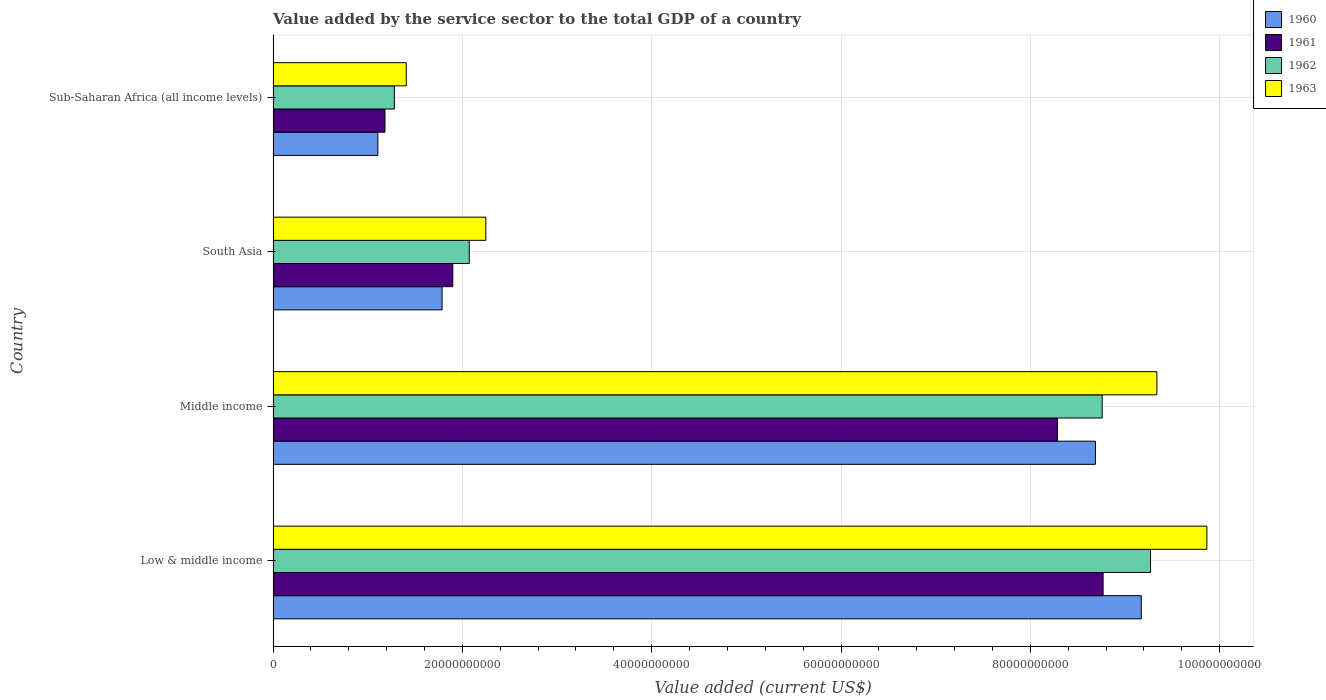How many different coloured bars are there?
Offer a terse response. 4. How many groups of bars are there?
Your response must be concise. 4. Are the number of bars on each tick of the Y-axis equal?
Ensure brevity in your answer.  Yes. What is the label of the 2nd group of bars from the top?
Keep it short and to the point. South Asia. What is the value added by the service sector to the total GDP in 1961 in South Asia?
Your response must be concise. 1.90e+1. Across all countries, what is the maximum value added by the service sector to the total GDP in 1962?
Offer a terse response. 9.27e+1. Across all countries, what is the minimum value added by the service sector to the total GDP in 1960?
Offer a very short reply. 1.11e+1. In which country was the value added by the service sector to the total GDP in 1962 maximum?
Offer a very short reply. Low & middle income. In which country was the value added by the service sector to the total GDP in 1961 minimum?
Provide a succinct answer. Sub-Saharan Africa (all income levels). What is the total value added by the service sector to the total GDP in 1962 in the graph?
Your answer should be compact. 2.14e+11. What is the difference between the value added by the service sector to the total GDP in 1962 in Low & middle income and that in South Asia?
Make the answer very short. 7.20e+1. What is the difference between the value added by the service sector to the total GDP in 1963 in Sub-Saharan Africa (all income levels) and the value added by the service sector to the total GDP in 1962 in Low & middle income?
Your response must be concise. -7.86e+1. What is the average value added by the service sector to the total GDP in 1961 per country?
Your answer should be compact. 5.03e+1. What is the difference between the value added by the service sector to the total GDP in 1961 and value added by the service sector to the total GDP in 1962 in Sub-Saharan Africa (all income levels)?
Your answer should be compact. -9.94e+08. What is the ratio of the value added by the service sector to the total GDP in 1961 in South Asia to that in Sub-Saharan Africa (all income levels)?
Keep it short and to the point. 1.61. Is the value added by the service sector to the total GDP in 1962 in Low & middle income less than that in Sub-Saharan Africa (all income levels)?
Provide a succinct answer. No. What is the difference between the highest and the second highest value added by the service sector to the total GDP in 1960?
Offer a terse response. 4.84e+09. What is the difference between the highest and the lowest value added by the service sector to the total GDP in 1963?
Provide a succinct answer. 8.46e+1. Is it the case that in every country, the sum of the value added by the service sector to the total GDP in 1963 and value added by the service sector to the total GDP in 1960 is greater than the sum of value added by the service sector to the total GDP in 1962 and value added by the service sector to the total GDP in 1961?
Your response must be concise. No. Does the graph contain any zero values?
Provide a short and direct response. No. How are the legend labels stacked?
Offer a terse response. Vertical. What is the title of the graph?
Provide a succinct answer. Value added by the service sector to the total GDP of a country. What is the label or title of the X-axis?
Your answer should be very brief. Value added (current US$). What is the label or title of the Y-axis?
Give a very brief answer. Country. What is the Value added (current US$) of 1960 in Low & middle income?
Keep it short and to the point. 9.17e+1. What is the Value added (current US$) of 1961 in Low & middle income?
Make the answer very short. 8.77e+1. What is the Value added (current US$) of 1962 in Low & middle income?
Your answer should be compact. 9.27e+1. What is the Value added (current US$) of 1963 in Low & middle income?
Your response must be concise. 9.87e+1. What is the Value added (current US$) in 1960 in Middle income?
Make the answer very short. 8.69e+1. What is the Value added (current US$) of 1961 in Middle income?
Your response must be concise. 8.29e+1. What is the Value added (current US$) in 1962 in Middle income?
Provide a short and direct response. 8.76e+1. What is the Value added (current US$) of 1963 in Middle income?
Your response must be concise. 9.34e+1. What is the Value added (current US$) of 1960 in South Asia?
Your response must be concise. 1.79e+1. What is the Value added (current US$) of 1961 in South Asia?
Offer a very short reply. 1.90e+1. What is the Value added (current US$) in 1962 in South Asia?
Provide a succinct answer. 2.07e+1. What is the Value added (current US$) in 1963 in South Asia?
Your answer should be compact. 2.25e+1. What is the Value added (current US$) of 1960 in Sub-Saharan Africa (all income levels)?
Your answer should be very brief. 1.11e+1. What is the Value added (current US$) in 1961 in Sub-Saharan Africa (all income levels)?
Give a very brief answer. 1.18e+1. What is the Value added (current US$) of 1962 in Sub-Saharan Africa (all income levels)?
Offer a terse response. 1.28e+1. What is the Value added (current US$) in 1963 in Sub-Saharan Africa (all income levels)?
Ensure brevity in your answer.  1.41e+1. Across all countries, what is the maximum Value added (current US$) in 1960?
Offer a terse response. 9.17e+1. Across all countries, what is the maximum Value added (current US$) of 1961?
Your answer should be compact. 8.77e+1. Across all countries, what is the maximum Value added (current US$) in 1962?
Offer a very short reply. 9.27e+1. Across all countries, what is the maximum Value added (current US$) in 1963?
Provide a succinct answer. 9.87e+1. Across all countries, what is the minimum Value added (current US$) in 1960?
Offer a very short reply. 1.11e+1. Across all countries, what is the minimum Value added (current US$) of 1961?
Offer a terse response. 1.18e+1. Across all countries, what is the minimum Value added (current US$) in 1962?
Provide a short and direct response. 1.28e+1. Across all countries, what is the minimum Value added (current US$) in 1963?
Ensure brevity in your answer.  1.41e+1. What is the total Value added (current US$) of 1960 in the graph?
Your response must be concise. 2.08e+11. What is the total Value added (current US$) in 1961 in the graph?
Offer a terse response. 2.01e+11. What is the total Value added (current US$) in 1962 in the graph?
Provide a short and direct response. 2.14e+11. What is the total Value added (current US$) in 1963 in the graph?
Make the answer very short. 2.29e+11. What is the difference between the Value added (current US$) in 1960 in Low & middle income and that in Middle income?
Keep it short and to the point. 4.84e+09. What is the difference between the Value added (current US$) of 1961 in Low & middle income and that in Middle income?
Keep it short and to the point. 4.82e+09. What is the difference between the Value added (current US$) in 1962 in Low & middle income and that in Middle income?
Your response must be concise. 5.11e+09. What is the difference between the Value added (current US$) in 1963 in Low & middle income and that in Middle income?
Your answer should be very brief. 5.28e+09. What is the difference between the Value added (current US$) of 1960 in Low & middle income and that in South Asia?
Give a very brief answer. 7.39e+1. What is the difference between the Value added (current US$) of 1961 in Low & middle income and that in South Asia?
Keep it short and to the point. 6.87e+1. What is the difference between the Value added (current US$) of 1962 in Low & middle income and that in South Asia?
Your response must be concise. 7.20e+1. What is the difference between the Value added (current US$) of 1963 in Low & middle income and that in South Asia?
Your answer should be compact. 7.62e+1. What is the difference between the Value added (current US$) in 1960 in Low & middle income and that in Sub-Saharan Africa (all income levels)?
Your answer should be compact. 8.07e+1. What is the difference between the Value added (current US$) of 1961 in Low & middle income and that in Sub-Saharan Africa (all income levels)?
Provide a succinct answer. 7.59e+1. What is the difference between the Value added (current US$) in 1962 in Low & middle income and that in Sub-Saharan Africa (all income levels)?
Offer a terse response. 7.99e+1. What is the difference between the Value added (current US$) in 1963 in Low & middle income and that in Sub-Saharan Africa (all income levels)?
Your answer should be compact. 8.46e+1. What is the difference between the Value added (current US$) of 1960 in Middle income and that in South Asia?
Offer a very short reply. 6.90e+1. What is the difference between the Value added (current US$) of 1961 in Middle income and that in South Asia?
Give a very brief answer. 6.39e+1. What is the difference between the Value added (current US$) of 1962 in Middle income and that in South Asia?
Your answer should be compact. 6.69e+1. What is the difference between the Value added (current US$) in 1963 in Middle income and that in South Asia?
Provide a succinct answer. 7.09e+1. What is the difference between the Value added (current US$) of 1960 in Middle income and that in Sub-Saharan Africa (all income levels)?
Your answer should be compact. 7.58e+1. What is the difference between the Value added (current US$) of 1961 in Middle income and that in Sub-Saharan Africa (all income levels)?
Your response must be concise. 7.11e+1. What is the difference between the Value added (current US$) of 1962 in Middle income and that in Sub-Saharan Africa (all income levels)?
Make the answer very short. 7.48e+1. What is the difference between the Value added (current US$) in 1963 in Middle income and that in Sub-Saharan Africa (all income levels)?
Provide a short and direct response. 7.93e+1. What is the difference between the Value added (current US$) of 1960 in South Asia and that in Sub-Saharan Africa (all income levels)?
Give a very brief answer. 6.79e+09. What is the difference between the Value added (current US$) of 1961 in South Asia and that in Sub-Saharan Africa (all income levels)?
Your answer should be compact. 7.17e+09. What is the difference between the Value added (current US$) in 1962 in South Asia and that in Sub-Saharan Africa (all income levels)?
Offer a terse response. 7.91e+09. What is the difference between the Value added (current US$) in 1963 in South Asia and that in Sub-Saharan Africa (all income levels)?
Provide a succinct answer. 8.41e+09. What is the difference between the Value added (current US$) in 1960 in Low & middle income and the Value added (current US$) in 1961 in Middle income?
Your answer should be compact. 8.85e+09. What is the difference between the Value added (current US$) of 1960 in Low & middle income and the Value added (current US$) of 1962 in Middle income?
Your answer should be compact. 4.13e+09. What is the difference between the Value added (current US$) of 1960 in Low & middle income and the Value added (current US$) of 1963 in Middle income?
Offer a terse response. -1.65e+09. What is the difference between the Value added (current US$) of 1961 in Low & middle income and the Value added (current US$) of 1962 in Middle income?
Make the answer very short. 9.90e+07. What is the difference between the Value added (current US$) in 1961 in Low & middle income and the Value added (current US$) in 1963 in Middle income?
Your response must be concise. -5.68e+09. What is the difference between the Value added (current US$) in 1962 in Low & middle income and the Value added (current US$) in 1963 in Middle income?
Ensure brevity in your answer.  -6.73e+08. What is the difference between the Value added (current US$) of 1960 in Low & middle income and the Value added (current US$) of 1961 in South Asia?
Make the answer very short. 7.27e+1. What is the difference between the Value added (current US$) of 1960 in Low & middle income and the Value added (current US$) of 1962 in South Asia?
Your answer should be compact. 7.10e+1. What is the difference between the Value added (current US$) of 1960 in Low & middle income and the Value added (current US$) of 1963 in South Asia?
Keep it short and to the point. 6.93e+1. What is the difference between the Value added (current US$) of 1961 in Low & middle income and the Value added (current US$) of 1962 in South Asia?
Offer a very short reply. 6.70e+1. What is the difference between the Value added (current US$) of 1961 in Low & middle income and the Value added (current US$) of 1963 in South Asia?
Provide a succinct answer. 6.52e+1. What is the difference between the Value added (current US$) in 1962 in Low & middle income and the Value added (current US$) in 1963 in South Asia?
Your answer should be compact. 7.02e+1. What is the difference between the Value added (current US$) of 1960 in Low & middle income and the Value added (current US$) of 1961 in Sub-Saharan Africa (all income levels)?
Make the answer very short. 7.99e+1. What is the difference between the Value added (current US$) in 1960 in Low & middle income and the Value added (current US$) in 1962 in Sub-Saharan Africa (all income levels)?
Your answer should be compact. 7.89e+1. What is the difference between the Value added (current US$) in 1960 in Low & middle income and the Value added (current US$) in 1963 in Sub-Saharan Africa (all income levels)?
Provide a succinct answer. 7.77e+1. What is the difference between the Value added (current US$) in 1961 in Low & middle income and the Value added (current US$) in 1962 in Sub-Saharan Africa (all income levels)?
Your answer should be very brief. 7.49e+1. What is the difference between the Value added (current US$) in 1961 in Low & middle income and the Value added (current US$) in 1963 in Sub-Saharan Africa (all income levels)?
Keep it short and to the point. 7.36e+1. What is the difference between the Value added (current US$) in 1962 in Low & middle income and the Value added (current US$) in 1963 in Sub-Saharan Africa (all income levels)?
Provide a succinct answer. 7.86e+1. What is the difference between the Value added (current US$) of 1960 in Middle income and the Value added (current US$) of 1961 in South Asia?
Offer a very short reply. 6.79e+1. What is the difference between the Value added (current US$) of 1960 in Middle income and the Value added (current US$) of 1962 in South Asia?
Make the answer very short. 6.62e+1. What is the difference between the Value added (current US$) in 1960 in Middle income and the Value added (current US$) in 1963 in South Asia?
Make the answer very short. 6.44e+1. What is the difference between the Value added (current US$) of 1961 in Middle income and the Value added (current US$) of 1962 in South Asia?
Your response must be concise. 6.22e+1. What is the difference between the Value added (current US$) of 1961 in Middle income and the Value added (current US$) of 1963 in South Asia?
Give a very brief answer. 6.04e+1. What is the difference between the Value added (current US$) in 1962 in Middle income and the Value added (current US$) in 1963 in South Asia?
Offer a terse response. 6.51e+1. What is the difference between the Value added (current US$) of 1960 in Middle income and the Value added (current US$) of 1961 in Sub-Saharan Africa (all income levels)?
Your answer should be compact. 7.51e+1. What is the difference between the Value added (current US$) in 1960 in Middle income and the Value added (current US$) in 1962 in Sub-Saharan Africa (all income levels)?
Provide a short and direct response. 7.41e+1. What is the difference between the Value added (current US$) of 1960 in Middle income and the Value added (current US$) of 1963 in Sub-Saharan Africa (all income levels)?
Keep it short and to the point. 7.28e+1. What is the difference between the Value added (current US$) in 1961 in Middle income and the Value added (current US$) in 1962 in Sub-Saharan Africa (all income levels)?
Give a very brief answer. 7.01e+1. What is the difference between the Value added (current US$) in 1961 in Middle income and the Value added (current US$) in 1963 in Sub-Saharan Africa (all income levels)?
Offer a very short reply. 6.88e+1. What is the difference between the Value added (current US$) of 1962 in Middle income and the Value added (current US$) of 1963 in Sub-Saharan Africa (all income levels)?
Make the answer very short. 7.35e+1. What is the difference between the Value added (current US$) in 1960 in South Asia and the Value added (current US$) in 1961 in Sub-Saharan Africa (all income levels)?
Your response must be concise. 6.03e+09. What is the difference between the Value added (current US$) in 1960 in South Asia and the Value added (current US$) in 1962 in Sub-Saharan Africa (all income levels)?
Keep it short and to the point. 5.04e+09. What is the difference between the Value added (current US$) in 1960 in South Asia and the Value added (current US$) in 1963 in Sub-Saharan Africa (all income levels)?
Make the answer very short. 3.78e+09. What is the difference between the Value added (current US$) in 1961 in South Asia and the Value added (current US$) in 1962 in Sub-Saharan Africa (all income levels)?
Your answer should be very brief. 6.17e+09. What is the difference between the Value added (current US$) in 1961 in South Asia and the Value added (current US$) in 1963 in Sub-Saharan Africa (all income levels)?
Keep it short and to the point. 4.91e+09. What is the difference between the Value added (current US$) in 1962 in South Asia and the Value added (current US$) in 1963 in Sub-Saharan Africa (all income levels)?
Provide a succinct answer. 6.65e+09. What is the average Value added (current US$) of 1960 per country?
Make the answer very short. 5.19e+1. What is the average Value added (current US$) of 1961 per country?
Ensure brevity in your answer.  5.03e+1. What is the average Value added (current US$) in 1962 per country?
Your answer should be very brief. 5.35e+1. What is the average Value added (current US$) in 1963 per country?
Offer a terse response. 5.71e+1. What is the difference between the Value added (current US$) of 1960 and Value added (current US$) of 1961 in Low & middle income?
Ensure brevity in your answer.  4.03e+09. What is the difference between the Value added (current US$) in 1960 and Value added (current US$) in 1962 in Low & middle income?
Your answer should be compact. -9.77e+08. What is the difference between the Value added (current US$) of 1960 and Value added (current US$) of 1963 in Low & middle income?
Offer a very short reply. -6.93e+09. What is the difference between the Value added (current US$) in 1961 and Value added (current US$) in 1962 in Low & middle income?
Provide a short and direct response. -5.01e+09. What is the difference between the Value added (current US$) of 1961 and Value added (current US$) of 1963 in Low & middle income?
Give a very brief answer. -1.10e+1. What is the difference between the Value added (current US$) in 1962 and Value added (current US$) in 1963 in Low & middle income?
Keep it short and to the point. -5.95e+09. What is the difference between the Value added (current US$) in 1960 and Value added (current US$) in 1961 in Middle income?
Offer a very short reply. 4.01e+09. What is the difference between the Value added (current US$) in 1960 and Value added (current US$) in 1962 in Middle income?
Offer a very short reply. -7.11e+08. What is the difference between the Value added (current US$) of 1960 and Value added (current US$) of 1963 in Middle income?
Your answer should be very brief. -6.49e+09. What is the difference between the Value added (current US$) of 1961 and Value added (current US$) of 1962 in Middle income?
Ensure brevity in your answer.  -4.72e+09. What is the difference between the Value added (current US$) of 1961 and Value added (current US$) of 1963 in Middle income?
Give a very brief answer. -1.05e+1. What is the difference between the Value added (current US$) of 1962 and Value added (current US$) of 1963 in Middle income?
Your answer should be compact. -5.78e+09. What is the difference between the Value added (current US$) of 1960 and Value added (current US$) of 1961 in South Asia?
Keep it short and to the point. -1.13e+09. What is the difference between the Value added (current US$) of 1960 and Value added (current US$) of 1962 in South Asia?
Provide a short and direct response. -2.87e+09. What is the difference between the Value added (current US$) in 1960 and Value added (current US$) in 1963 in South Asia?
Your response must be concise. -4.62e+09. What is the difference between the Value added (current US$) of 1961 and Value added (current US$) of 1962 in South Asia?
Keep it short and to the point. -1.74e+09. What is the difference between the Value added (current US$) of 1961 and Value added (current US$) of 1963 in South Asia?
Offer a terse response. -3.49e+09. What is the difference between the Value added (current US$) of 1962 and Value added (current US$) of 1963 in South Asia?
Make the answer very short. -1.75e+09. What is the difference between the Value added (current US$) in 1960 and Value added (current US$) in 1961 in Sub-Saharan Africa (all income levels)?
Your answer should be compact. -7.53e+08. What is the difference between the Value added (current US$) in 1960 and Value added (current US$) in 1962 in Sub-Saharan Africa (all income levels)?
Your response must be concise. -1.75e+09. What is the difference between the Value added (current US$) of 1960 and Value added (current US$) of 1963 in Sub-Saharan Africa (all income levels)?
Keep it short and to the point. -3.01e+09. What is the difference between the Value added (current US$) in 1961 and Value added (current US$) in 1962 in Sub-Saharan Africa (all income levels)?
Give a very brief answer. -9.94e+08. What is the difference between the Value added (current US$) of 1961 and Value added (current US$) of 1963 in Sub-Saharan Africa (all income levels)?
Offer a terse response. -2.25e+09. What is the difference between the Value added (current US$) of 1962 and Value added (current US$) of 1963 in Sub-Saharan Africa (all income levels)?
Keep it short and to the point. -1.26e+09. What is the ratio of the Value added (current US$) in 1960 in Low & middle income to that in Middle income?
Offer a terse response. 1.06. What is the ratio of the Value added (current US$) of 1961 in Low & middle income to that in Middle income?
Your answer should be compact. 1.06. What is the ratio of the Value added (current US$) of 1962 in Low & middle income to that in Middle income?
Keep it short and to the point. 1.06. What is the ratio of the Value added (current US$) in 1963 in Low & middle income to that in Middle income?
Offer a terse response. 1.06. What is the ratio of the Value added (current US$) of 1960 in Low & middle income to that in South Asia?
Make the answer very short. 5.14. What is the ratio of the Value added (current US$) in 1961 in Low & middle income to that in South Asia?
Make the answer very short. 4.62. What is the ratio of the Value added (current US$) of 1962 in Low & middle income to that in South Asia?
Provide a succinct answer. 4.47. What is the ratio of the Value added (current US$) in 1963 in Low & middle income to that in South Asia?
Your response must be concise. 4.39. What is the ratio of the Value added (current US$) in 1960 in Low & middle income to that in Sub-Saharan Africa (all income levels)?
Ensure brevity in your answer.  8.29. What is the ratio of the Value added (current US$) in 1961 in Low & middle income to that in Sub-Saharan Africa (all income levels)?
Your answer should be compact. 7.42. What is the ratio of the Value added (current US$) of 1962 in Low & middle income to that in Sub-Saharan Africa (all income levels)?
Give a very brief answer. 7.24. What is the ratio of the Value added (current US$) of 1963 in Low & middle income to that in Sub-Saharan Africa (all income levels)?
Offer a terse response. 7.01. What is the ratio of the Value added (current US$) of 1960 in Middle income to that in South Asia?
Your response must be concise. 4.87. What is the ratio of the Value added (current US$) in 1961 in Middle income to that in South Asia?
Your answer should be compact. 4.37. What is the ratio of the Value added (current US$) of 1962 in Middle income to that in South Asia?
Ensure brevity in your answer.  4.23. What is the ratio of the Value added (current US$) of 1963 in Middle income to that in South Asia?
Make the answer very short. 4.15. What is the ratio of the Value added (current US$) of 1960 in Middle income to that in Sub-Saharan Africa (all income levels)?
Offer a terse response. 7.85. What is the ratio of the Value added (current US$) in 1961 in Middle income to that in Sub-Saharan Africa (all income levels)?
Keep it short and to the point. 7.01. What is the ratio of the Value added (current US$) of 1962 in Middle income to that in Sub-Saharan Africa (all income levels)?
Provide a short and direct response. 6.84. What is the ratio of the Value added (current US$) of 1963 in Middle income to that in Sub-Saharan Africa (all income levels)?
Your response must be concise. 6.64. What is the ratio of the Value added (current US$) in 1960 in South Asia to that in Sub-Saharan Africa (all income levels)?
Make the answer very short. 1.61. What is the ratio of the Value added (current US$) of 1961 in South Asia to that in Sub-Saharan Africa (all income levels)?
Give a very brief answer. 1.61. What is the ratio of the Value added (current US$) of 1962 in South Asia to that in Sub-Saharan Africa (all income levels)?
Your answer should be compact. 1.62. What is the ratio of the Value added (current US$) in 1963 in South Asia to that in Sub-Saharan Africa (all income levels)?
Offer a very short reply. 1.6. What is the difference between the highest and the second highest Value added (current US$) in 1960?
Keep it short and to the point. 4.84e+09. What is the difference between the highest and the second highest Value added (current US$) in 1961?
Provide a short and direct response. 4.82e+09. What is the difference between the highest and the second highest Value added (current US$) of 1962?
Provide a succinct answer. 5.11e+09. What is the difference between the highest and the second highest Value added (current US$) in 1963?
Make the answer very short. 5.28e+09. What is the difference between the highest and the lowest Value added (current US$) in 1960?
Your response must be concise. 8.07e+1. What is the difference between the highest and the lowest Value added (current US$) in 1961?
Make the answer very short. 7.59e+1. What is the difference between the highest and the lowest Value added (current US$) of 1962?
Provide a succinct answer. 7.99e+1. What is the difference between the highest and the lowest Value added (current US$) in 1963?
Offer a very short reply. 8.46e+1. 